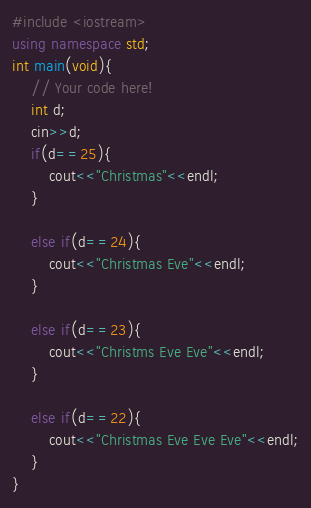<code> <loc_0><loc_0><loc_500><loc_500><_C++_>#include <iostream>
using namespace std;
int main(void){
    // Your code here!
    int d;
    cin>>d;
    if(d==25){
        cout<<"Christmas"<<endl;
    }
    
    else if(d==24){
        cout<<"Christmas Eve"<<endl;
    }
    
    else if(d==23){
        cout<<"Christms Eve Eve"<<endl;
    }
    
    else if(d==22){
        cout<<"Christmas Eve Eve Eve"<<endl;
    }
}
</code> 